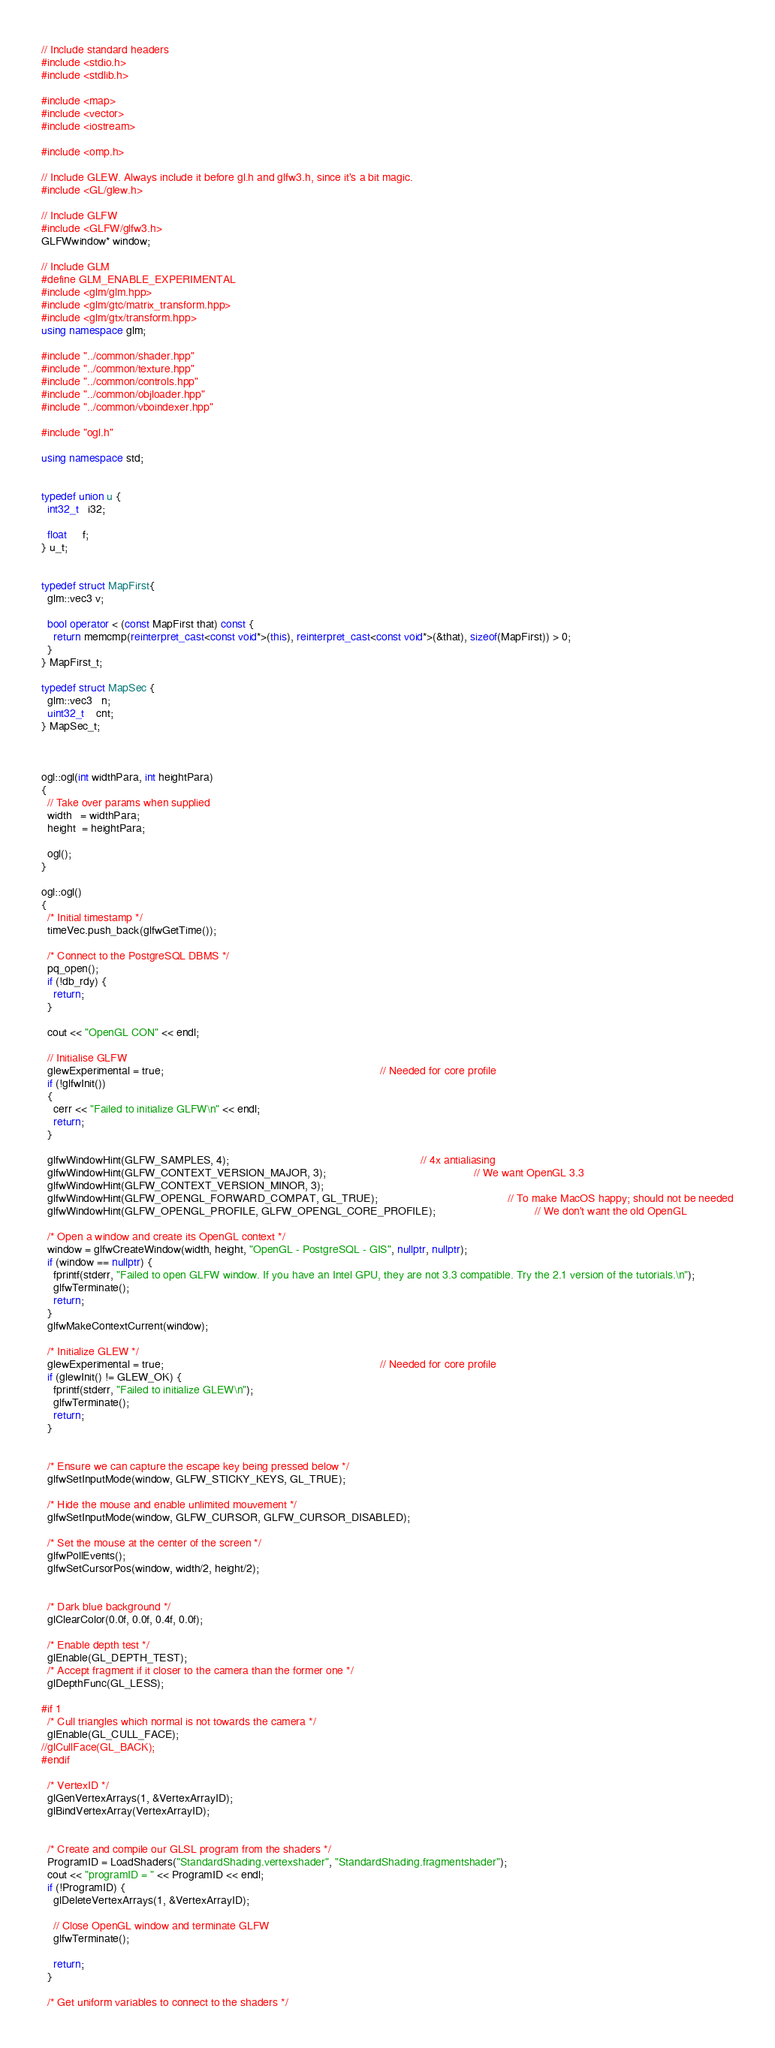<code> <loc_0><loc_0><loc_500><loc_500><_C++_>// Include standard headers
#include <stdio.h>
#include <stdlib.h>

#include <map>
#include <vector>
#include <iostream>

#include <omp.h>

// Include GLEW. Always include it before gl.h and glfw3.h, since it's a bit magic.
#include <GL/glew.h>

// Include GLFW
#include <GLFW/glfw3.h>
GLFWwindow* window;

// Include GLM
#define GLM_ENABLE_EXPERIMENTAL
#include <glm/glm.hpp>
#include <glm/gtc/matrix_transform.hpp>
#include <glm/gtx/transform.hpp>
using namespace glm;

#include "../common/shader.hpp"
#include "../common/texture.hpp"
#include "../common/controls.hpp"
#include "../common/objloader.hpp"
#include "../common/vboindexer.hpp"

#include "ogl.h"

using namespace std;


typedef union u {
  int32_t   i32;

  float     f;
} u_t;


typedef struct MapFirst{
  glm::vec3 v;

  bool operator < (const MapFirst that) const {
    return memcmp(reinterpret_cast<const void*>(this), reinterpret_cast<const void*>(&that), sizeof(MapFirst)) > 0;
  }
} MapFirst_t;

typedef struct MapSec {
  glm::vec3   n;
  uint32_t    cnt;
} MapSec_t;



ogl::ogl(int widthPara, int heightPara)
{
  // Take over params when supplied
  width   = widthPara;
  height  = heightPara;

  ogl();
}

ogl::ogl()
{
  /* Initial timestamp */
  timeVec.push_back(glfwGetTime());

  /* Connect to the PostgreSQL DBMS */
  pq_open();
  if (!db_rdy) {
    return;
  }

  cout << "OpenGL CON" << endl;

  // Initialise GLFW
  glewExperimental = true;                                                                      // Needed for core profile
  if (!glfwInit())
  {
    cerr << "Failed to initialize GLFW\n" << endl;
    return;
  }

  glfwWindowHint(GLFW_SAMPLES, 4);                                                              // 4x antialiasing
  glfwWindowHint(GLFW_CONTEXT_VERSION_MAJOR, 3);                                                // We want OpenGL 3.3
  glfwWindowHint(GLFW_CONTEXT_VERSION_MINOR, 3);
  glfwWindowHint(GLFW_OPENGL_FORWARD_COMPAT, GL_TRUE);                                          // To make MacOS happy; should not be needed
  glfwWindowHint(GLFW_OPENGL_PROFILE, GLFW_OPENGL_CORE_PROFILE);                                // We don't want the old OpenGL

  /* Open a window and create its OpenGL context */
  window = glfwCreateWindow(width, height, "OpenGL - PostgreSQL - GIS", nullptr, nullptr);
  if (window == nullptr) {
    fprintf(stderr, "Failed to open GLFW window. If you have an Intel GPU, they are not 3.3 compatible. Try the 2.1 version of the tutorials.\n");
    glfwTerminate();
    return;
  }
  glfwMakeContextCurrent(window);

  /* Initialize GLEW */
  glewExperimental = true;                                                                      // Needed for core profile
  if (glewInit() != GLEW_OK) {
    fprintf(stderr, "Failed to initialize GLEW\n");
    glfwTerminate();
    return;
  }


  /* Ensure we can capture the escape key being pressed below */
  glfwSetInputMode(window, GLFW_STICKY_KEYS, GL_TRUE);

  /* Hide the mouse and enable unlimited mouvement */
  glfwSetInputMode(window, GLFW_CURSOR, GLFW_CURSOR_DISABLED);

  /* Set the mouse at the center of the screen */
  glfwPollEvents();
  glfwSetCursorPos(window, width/2, height/2);


  /* Dark blue background */
  glClearColor(0.0f, 0.0f, 0.4f, 0.0f);

  /* Enable depth test */
  glEnable(GL_DEPTH_TEST);
  /* Accept fragment if it closer to the camera than the former one */
  glDepthFunc(GL_LESS);

#if 1
  /* Cull triangles which normal is not towards the camera */
  glEnable(GL_CULL_FACE);
//glCullFace(GL_BACK);
#endif

  /* VertexID */
  glGenVertexArrays(1, &VertexArrayID);
  glBindVertexArray(VertexArrayID);


  /* Create and compile our GLSL program from the shaders */
  ProgramID = LoadShaders("StandardShading.vertexshader", "StandardShading.fragmentshader");
  cout << "programID = " << ProgramID << endl;
  if (!ProgramID) {
    glDeleteVertexArrays(1, &VertexArrayID);

    // Close OpenGL window and terminate GLFW
    glfwTerminate();

    return;
  }

  /* Get uniform variables to connect to the shaders */</code> 